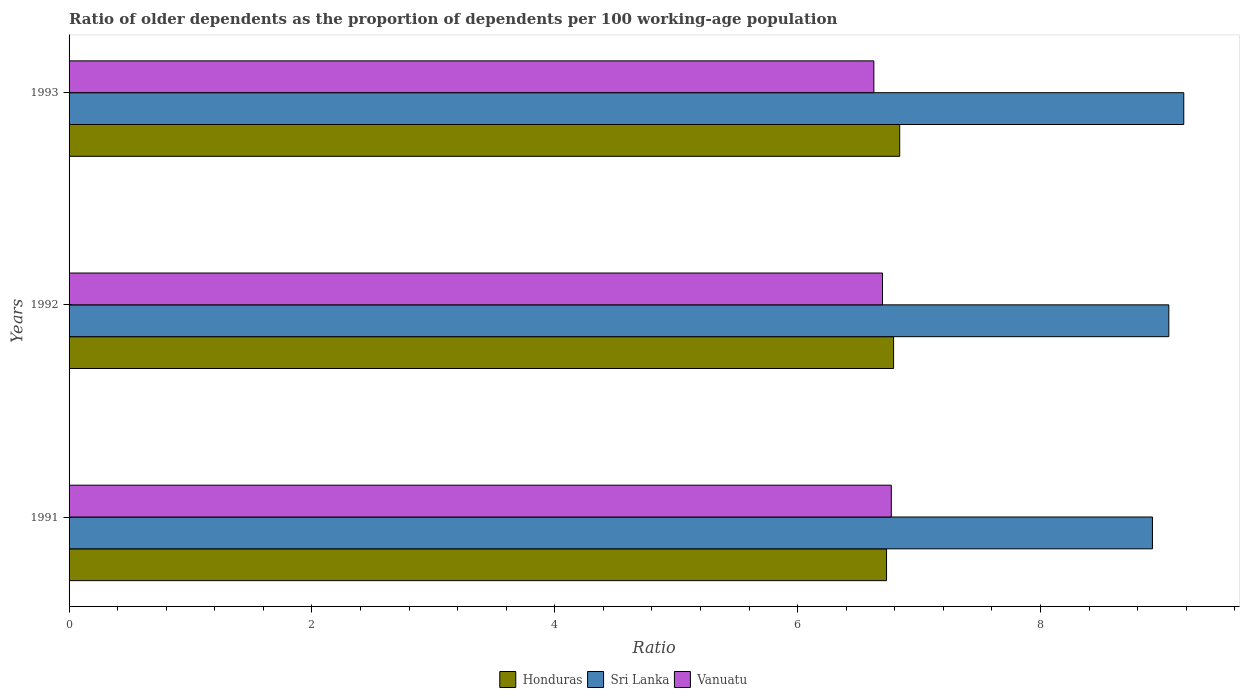How many different coloured bars are there?
Offer a very short reply. 3. How many groups of bars are there?
Offer a terse response. 3. Are the number of bars on each tick of the Y-axis equal?
Provide a succinct answer. Yes. What is the label of the 3rd group of bars from the top?
Your response must be concise. 1991. What is the age dependency ratio(old) in Sri Lanka in 1993?
Ensure brevity in your answer.  9.18. Across all years, what is the maximum age dependency ratio(old) in Sri Lanka?
Make the answer very short. 9.18. Across all years, what is the minimum age dependency ratio(old) in Honduras?
Provide a succinct answer. 6.73. What is the total age dependency ratio(old) in Vanuatu in the graph?
Your answer should be compact. 20.1. What is the difference between the age dependency ratio(old) in Vanuatu in 1991 and that in 1993?
Offer a very short reply. 0.14. What is the difference between the age dependency ratio(old) in Vanuatu in 1993 and the age dependency ratio(old) in Honduras in 1991?
Give a very brief answer. -0.1. What is the average age dependency ratio(old) in Vanuatu per year?
Offer a terse response. 6.7. In the year 1992, what is the difference between the age dependency ratio(old) in Honduras and age dependency ratio(old) in Sri Lanka?
Provide a short and direct response. -2.27. In how many years, is the age dependency ratio(old) in Honduras greater than 6.4 ?
Make the answer very short. 3. What is the ratio of the age dependency ratio(old) in Vanuatu in 1992 to that in 1993?
Keep it short and to the point. 1.01. What is the difference between the highest and the second highest age dependency ratio(old) in Honduras?
Your answer should be compact. 0.05. What is the difference between the highest and the lowest age dependency ratio(old) in Honduras?
Your answer should be very brief. 0.11. What does the 1st bar from the top in 1991 represents?
Make the answer very short. Vanuatu. What does the 1st bar from the bottom in 1992 represents?
Ensure brevity in your answer.  Honduras. Is it the case that in every year, the sum of the age dependency ratio(old) in Sri Lanka and age dependency ratio(old) in Honduras is greater than the age dependency ratio(old) in Vanuatu?
Ensure brevity in your answer.  Yes. Are all the bars in the graph horizontal?
Offer a very short reply. Yes. How many years are there in the graph?
Give a very brief answer. 3. What is the difference between two consecutive major ticks on the X-axis?
Your answer should be compact. 2. Where does the legend appear in the graph?
Keep it short and to the point. Bottom center. How are the legend labels stacked?
Your answer should be very brief. Horizontal. What is the title of the graph?
Provide a succinct answer. Ratio of older dependents as the proportion of dependents per 100 working-age population. Does "Dominican Republic" appear as one of the legend labels in the graph?
Offer a very short reply. No. What is the label or title of the X-axis?
Your answer should be compact. Ratio. What is the Ratio of Honduras in 1991?
Give a very brief answer. 6.73. What is the Ratio of Sri Lanka in 1991?
Your answer should be compact. 8.92. What is the Ratio of Vanuatu in 1991?
Give a very brief answer. 6.77. What is the Ratio of Honduras in 1992?
Make the answer very short. 6.79. What is the Ratio in Sri Lanka in 1992?
Make the answer very short. 9.06. What is the Ratio of Vanuatu in 1992?
Ensure brevity in your answer.  6.7. What is the Ratio of Honduras in 1993?
Ensure brevity in your answer.  6.84. What is the Ratio in Sri Lanka in 1993?
Keep it short and to the point. 9.18. What is the Ratio in Vanuatu in 1993?
Offer a terse response. 6.63. Across all years, what is the maximum Ratio in Honduras?
Keep it short and to the point. 6.84. Across all years, what is the maximum Ratio in Sri Lanka?
Your answer should be compact. 9.18. Across all years, what is the maximum Ratio in Vanuatu?
Provide a short and direct response. 6.77. Across all years, what is the minimum Ratio of Honduras?
Ensure brevity in your answer.  6.73. Across all years, what is the minimum Ratio in Sri Lanka?
Your response must be concise. 8.92. Across all years, what is the minimum Ratio of Vanuatu?
Your answer should be compact. 6.63. What is the total Ratio of Honduras in the graph?
Your answer should be compact. 20.36. What is the total Ratio of Sri Lanka in the graph?
Your response must be concise. 27.16. What is the total Ratio in Vanuatu in the graph?
Give a very brief answer. 20.1. What is the difference between the Ratio in Honduras in 1991 and that in 1992?
Offer a terse response. -0.06. What is the difference between the Ratio in Sri Lanka in 1991 and that in 1992?
Offer a very short reply. -0.13. What is the difference between the Ratio of Vanuatu in 1991 and that in 1992?
Keep it short and to the point. 0.07. What is the difference between the Ratio in Honduras in 1991 and that in 1993?
Ensure brevity in your answer.  -0.11. What is the difference between the Ratio of Sri Lanka in 1991 and that in 1993?
Provide a succinct answer. -0.26. What is the difference between the Ratio in Vanuatu in 1991 and that in 1993?
Offer a very short reply. 0.14. What is the difference between the Ratio of Honduras in 1992 and that in 1993?
Provide a succinct answer. -0.05. What is the difference between the Ratio in Sri Lanka in 1992 and that in 1993?
Offer a terse response. -0.12. What is the difference between the Ratio of Vanuatu in 1992 and that in 1993?
Your answer should be compact. 0.07. What is the difference between the Ratio in Honduras in 1991 and the Ratio in Sri Lanka in 1992?
Give a very brief answer. -2.32. What is the difference between the Ratio in Honduras in 1991 and the Ratio in Vanuatu in 1992?
Make the answer very short. 0.03. What is the difference between the Ratio of Sri Lanka in 1991 and the Ratio of Vanuatu in 1992?
Your answer should be compact. 2.22. What is the difference between the Ratio in Honduras in 1991 and the Ratio in Sri Lanka in 1993?
Ensure brevity in your answer.  -2.45. What is the difference between the Ratio of Honduras in 1991 and the Ratio of Vanuatu in 1993?
Ensure brevity in your answer.  0.1. What is the difference between the Ratio of Sri Lanka in 1991 and the Ratio of Vanuatu in 1993?
Ensure brevity in your answer.  2.29. What is the difference between the Ratio of Honduras in 1992 and the Ratio of Sri Lanka in 1993?
Give a very brief answer. -2.39. What is the difference between the Ratio in Honduras in 1992 and the Ratio in Vanuatu in 1993?
Provide a succinct answer. 0.16. What is the difference between the Ratio in Sri Lanka in 1992 and the Ratio in Vanuatu in 1993?
Your answer should be compact. 2.43. What is the average Ratio in Honduras per year?
Your answer should be very brief. 6.79. What is the average Ratio of Sri Lanka per year?
Provide a succinct answer. 9.05. What is the average Ratio in Vanuatu per year?
Your response must be concise. 6.7. In the year 1991, what is the difference between the Ratio of Honduras and Ratio of Sri Lanka?
Give a very brief answer. -2.19. In the year 1991, what is the difference between the Ratio in Honduras and Ratio in Vanuatu?
Your answer should be very brief. -0.04. In the year 1991, what is the difference between the Ratio in Sri Lanka and Ratio in Vanuatu?
Your response must be concise. 2.15. In the year 1992, what is the difference between the Ratio of Honduras and Ratio of Sri Lanka?
Offer a very short reply. -2.27. In the year 1992, what is the difference between the Ratio in Honduras and Ratio in Vanuatu?
Ensure brevity in your answer.  0.09. In the year 1992, what is the difference between the Ratio in Sri Lanka and Ratio in Vanuatu?
Offer a terse response. 2.36. In the year 1993, what is the difference between the Ratio of Honduras and Ratio of Sri Lanka?
Your response must be concise. -2.34. In the year 1993, what is the difference between the Ratio in Honduras and Ratio in Vanuatu?
Provide a short and direct response. 0.21. In the year 1993, what is the difference between the Ratio of Sri Lanka and Ratio of Vanuatu?
Ensure brevity in your answer.  2.55. What is the ratio of the Ratio in Honduras in 1991 to that in 1992?
Offer a very short reply. 0.99. What is the ratio of the Ratio in Sri Lanka in 1991 to that in 1992?
Ensure brevity in your answer.  0.99. What is the ratio of the Ratio in Vanuatu in 1991 to that in 1992?
Your answer should be compact. 1.01. What is the ratio of the Ratio in Honduras in 1991 to that in 1993?
Keep it short and to the point. 0.98. What is the ratio of the Ratio in Sri Lanka in 1991 to that in 1993?
Provide a succinct answer. 0.97. What is the ratio of the Ratio of Vanuatu in 1991 to that in 1993?
Your answer should be very brief. 1.02. What is the ratio of the Ratio of Sri Lanka in 1992 to that in 1993?
Make the answer very short. 0.99. What is the ratio of the Ratio in Vanuatu in 1992 to that in 1993?
Give a very brief answer. 1.01. What is the difference between the highest and the second highest Ratio of Honduras?
Your answer should be very brief. 0.05. What is the difference between the highest and the second highest Ratio in Sri Lanka?
Your response must be concise. 0.12. What is the difference between the highest and the second highest Ratio in Vanuatu?
Your answer should be compact. 0.07. What is the difference between the highest and the lowest Ratio in Honduras?
Offer a very short reply. 0.11. What is the difference between the highest and the lowest Ratio in Sri Lanka?
Make the answer very short. 0.26. What is the difference between the highest and the lowest Ratio of Vanuatu?
Provide a short and direct response. 0.14. 